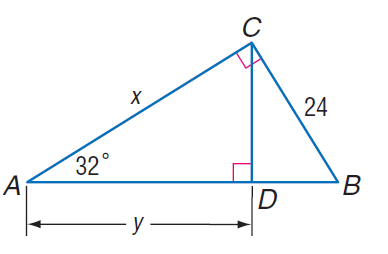Question: Find x.
Choices:
A. 21.1
B. 23.4
C. 38.4
D. 45.3
Answer with the letter. Answer: C Question: Find y.
Choices:
A. 21.4
B. 24.1
C. 32.6
D. 43.1
Answer with the letter. Answer: C 